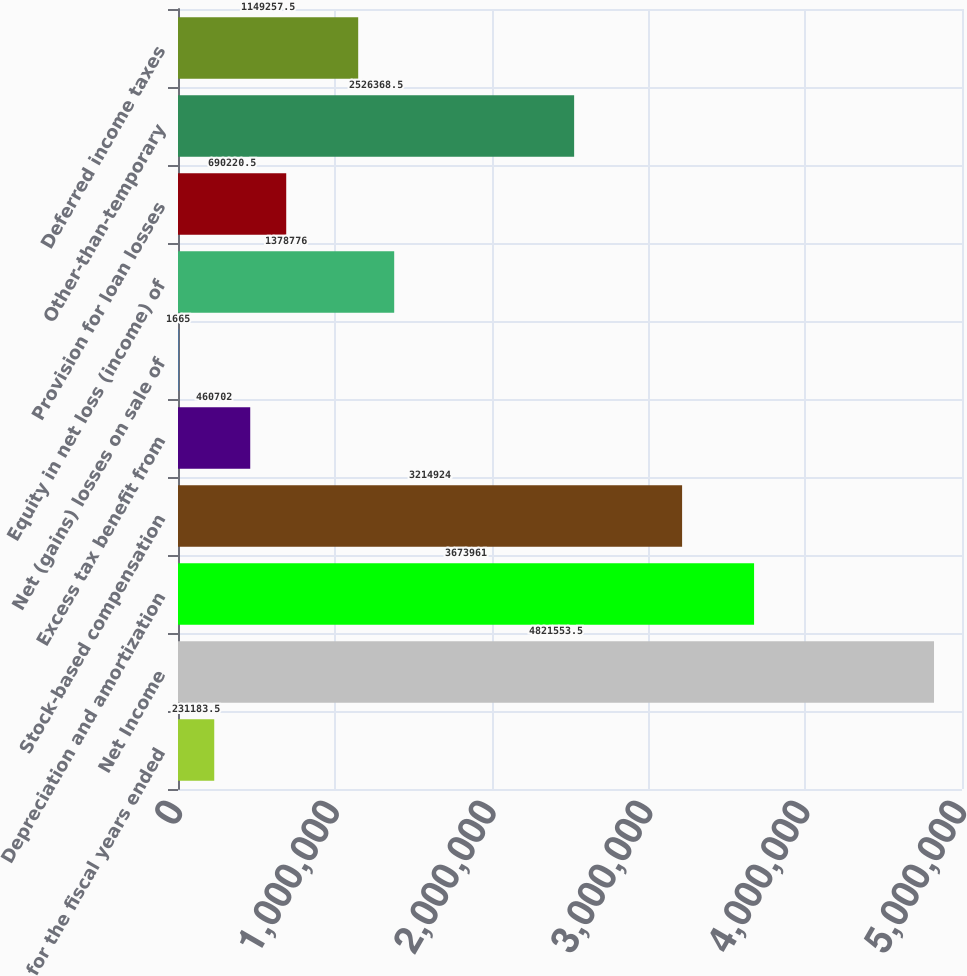<chart> <loc_0><loc_0><loc_500><loc_500><bar_chart><fcel>for the fiscal years ended<fcel>Net Income<fcel>Depreciation and amortization<fcel>Stock-based compensation<fcel>Excess tax benefit from<fcel>Net (gains) losses on sale of<fcel>Equity in net loss (income) of<fcel>Provision for loan losses<fcel>Other-than-temporary<fcel>Deferred income taxes<nl><fcel>231184<fcel>4.82155e+06<fcel>3.67396e+06<fcel>3.21492e+06<fcel>460702<fcel>1665<fcel>1.37878e+06<fcel>690220<fcel>2.52637e+06<fcel>1.14926e+06<nl></chart> 